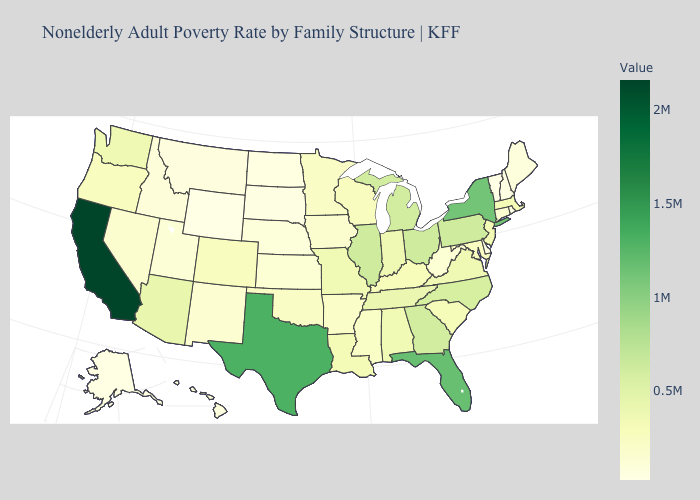Which states hav the highest value in the MidWest?
Give a very brief answer. Illinois. Among the states that border Nevada , which have the highest value?
Be succinct. California. Does New York have the lowest value in the Northeast?
Give a very brief answer. No. Does Delaware have the lowest value in the South?
Concise answer only. Yes. Which states hav the highest value in the West?
Write a very short answer. California. Does Georgia have a higher value than Louisiana?
Short answer required. Yes. Does Utah have the lowest value in the USA?
Write a very short answer. No. 